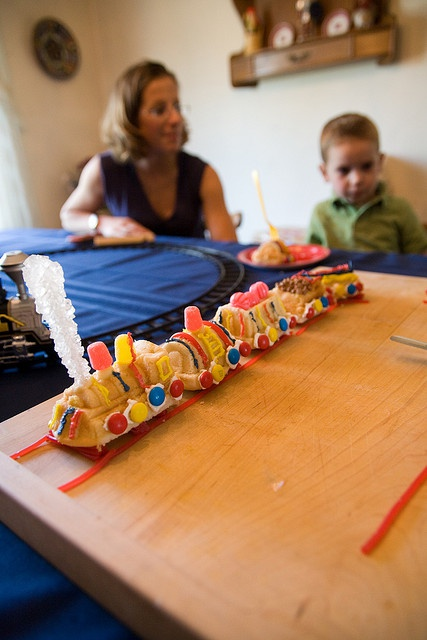Describe the objects in this image and their specific colors. I can see dining table in gray, tan, orange, and black tones, people in gray, black, maroon, brown, and lightgray tones, cake in gray, lightgray, red, orange, and tan tones, people in gray, olive, maroon, black, and tan tones, and cake in gray, orange, tan, and red tones in this image. 